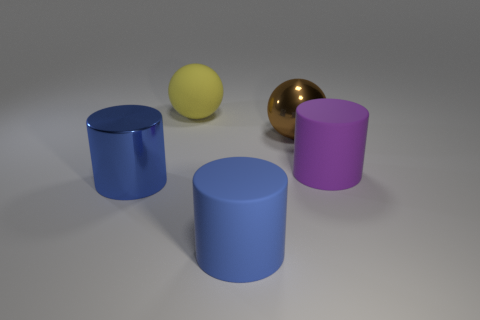There is a large yellow matte object; are there any brown objects behind it?
Your answer should be very brief. No. What color is the other object that is the same shape as the big brown shiny thing?
Give a very brief answer. Yellow. Are there any other things that have the same shape as the large blue shiny thing?
Your answer should be very brief. Yes. What material is the big cylinder that is right of the brown object?
Your answer should be very brief. Rubber. The brown object that is the same shape as the yellow matte thing is what size?
Provide a short and direct response. Large. How many cylinders have the same material as the large purple object?
Your answer should be very brief. 1. What number of metallic objects have the same color as the metal ball?
Keep it short and to the point. 0. How many things are either large yellow matte balls that are on the left side of the brown thing or large objects that are in front of the matte ball?
Your response must be concise. 5. Is the number of big brown spheres that are in front of the purple object less than the number of cyan blocks?
Keep it short and to the point. No. Is there a yellow ball that has the same size as the blue shiny cylinder?
Ensure brevity in your answer.  Yes. 